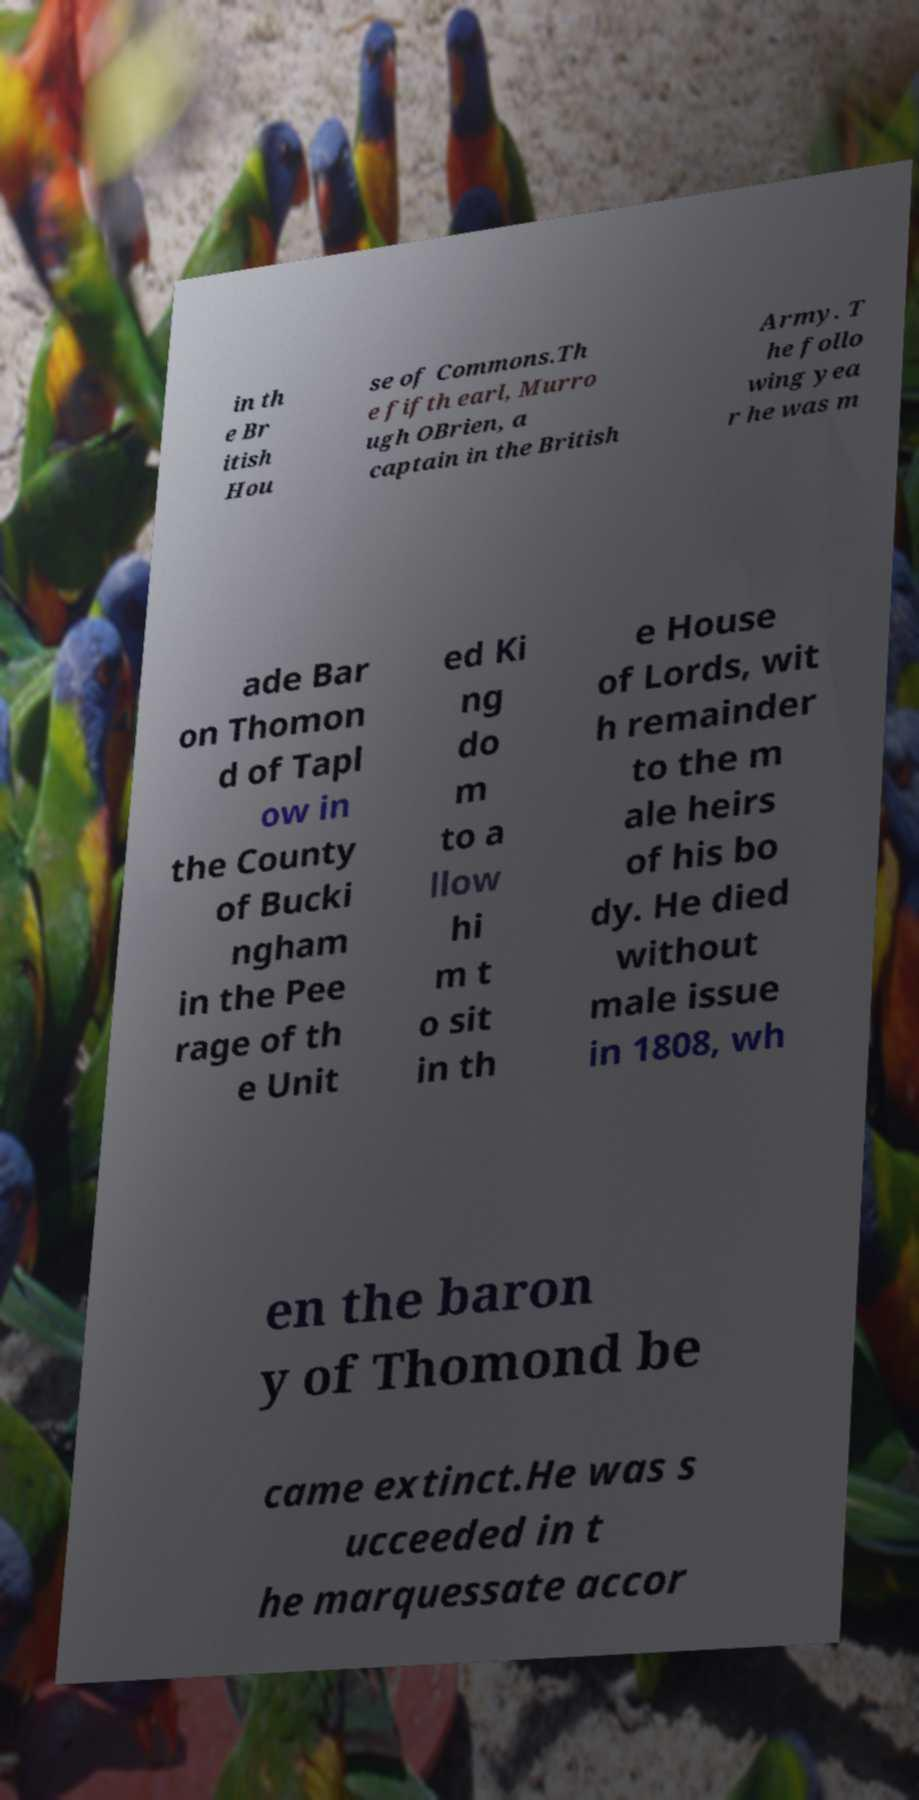Please identify and transcribe the text found in this image. in th e Br itish Hou se of Commons.Th e fifth earl, Murro ugh OBrien, a captain in the British Army. T he follo wing yea r he was m ade Bar on Thomon d of Tapl ow in the County of Bucki ngham in the Pee rage of th e Unit ed Ki ng do m to a llow hi m t o sit in th e House of Lords, wit h remainder to the m ale heirs of his bo dy. He died without male issue in 1808, wh en the baron y of Thomond be came extinct.He was s ucceeded in t he marquessate accor 